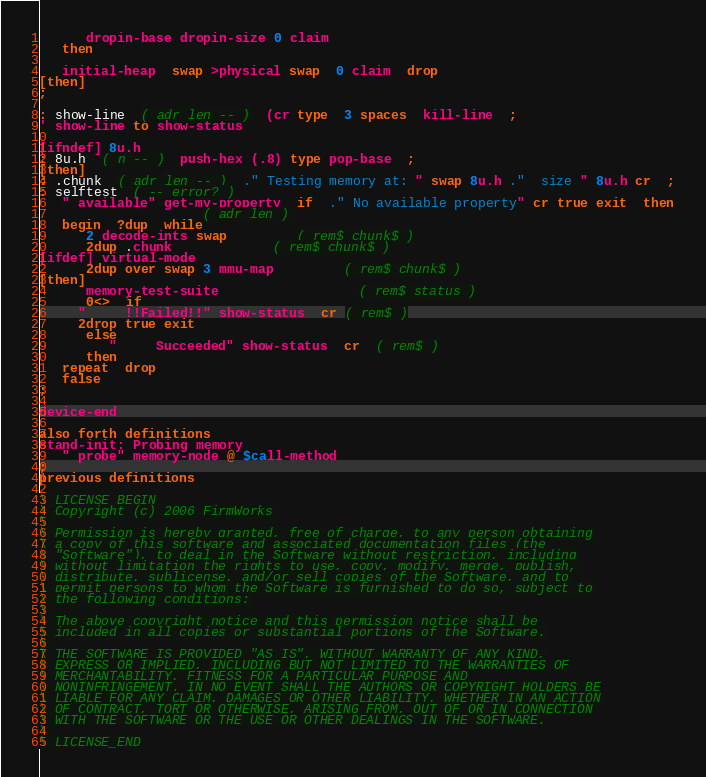<code> <loc_0><loc_0><loc_500><loc_500><_Forth_>      dropin-base dropin-size 0 claim
   then

   initial-heap  swap >physical swap  0 claim  drop
[then]
;

: show-line  ( adr len -- )  (cr type  3 spaces  kill-line  ;
' show-line to show-status

[ifndef] 8u.h
: 8u.h  ( n -- )  push-hex (.8) type pop-base  ;
[then]
: .chunk  ( adr len -- )  ." Testing memory at: " swap 8u.h ."  size " 8u.h cr  ;
: selftest  ( -- error? )
   " available" get-my-property  if  ." No available property" cr true exit  then
					 ( adr len )
   begin  ?dup  while
      2 decode-ints swap		 ( rem$ chunk$ )
      2dup .chunk			 ( rem$ chunk$ )
[ifdef] virtual-mode
      2dup over swap 3 mmu-map		 ( rem$ chunk$ )
[then]
      memory-test-suite                  ( rem$ status )
      0<>  if
	 "     !!Failed!!" show-status  cr ( rem$ )
	 2drop true exit
      else
         "     Succeeded" show-status  cr  ( rem$ )
      then
   repeat  drop
   false
;

device-end

also forth definitions
stand-init: Probing memory
   " probe" memory-node @ $call-method  
;
previous definitions

\ LICENSE_BEGIN
\ Copyright (c) 2006 FirmWorks
\ 
\ Permission is hereby granted, free of charge, to any person obtaining
\ a copy of this software and associated documentation files (the
\ "Software"), to deal in the Software without restriction, including
\ without limitation the rights to use, copy, modify, merge, publish,
\ distribute, sublicense, and/or sell copies of the Software, and to
\ permit persons to whom the Software is furnished to do so, subject to
\ the following conditions:
\ 
\ The above copyright notice and this permission notice shall be
\ included in all copies or substantial portions of the Software.
\ 
\ THE SOFTWARE IS PROVIDED "AS IS", WITHOUT WARRANTY OF ANY KIND,
\ EXPRESS OR IMPLIED, INCLUDING BUT NOT LIMITED TO THE WARRANTIES OF
\ MERCHANTABILITY, FITNESS FOR A PARTICULAR PURPOSE AND
\ NONINFRINGEMENT. IN NO EVENT SHALL THE AUTHORS OR COPYRIGHT HOLDERS BE
\ LIABLE FOR ANY CLAIM, DAMAGES OR OTHER LIABILITY, WHETHER IN AN ACTION
\ OF CONTRACT, TORT OR OTHERWISE, ARISING FROM, OUT OF OR IN CONNECTION
\ WITH THE SOFTWARE OR THE USE OR OTHER DEALINGS IN THE SOFTWARE.
\
\ LICENSE_END
</code> 